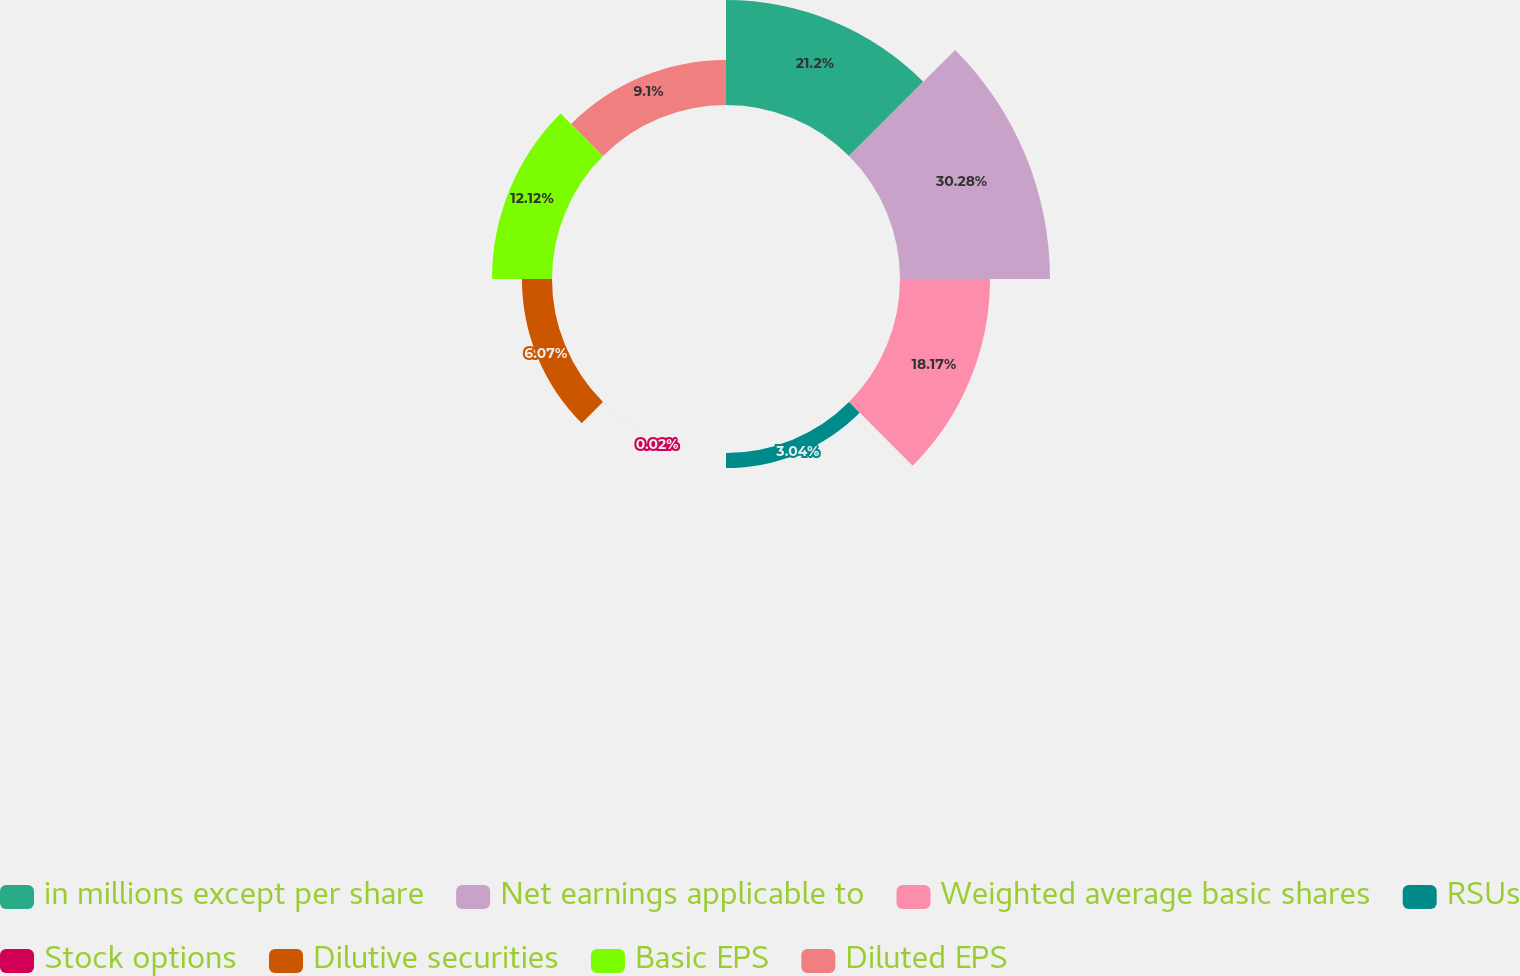Convert chart to OTSL. <chart><loc_0><loc_0><loc_500><loc_500><pie_chart><fcel>in millions except per share<fcel>Net earnings applicable to<fcel>Weighted average basic shares<fcel>RSUs<fcel>Stock options<fcel>Dilutive securities<fcel>Basic EPS<fcel>Diluted EPS<nl><fcel>21.2%<fcel>30.28%<fcel>18.17%<fcel>3.04%<fcel>0.02%<fcel>6.07%<fcel>12.12%<fcel>9.1%<nl></chart> 